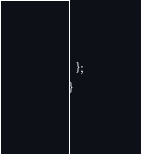<code> <loc_0><loc_0><loc_500><loc_500><_TypeScript_>  };
}
</code> 